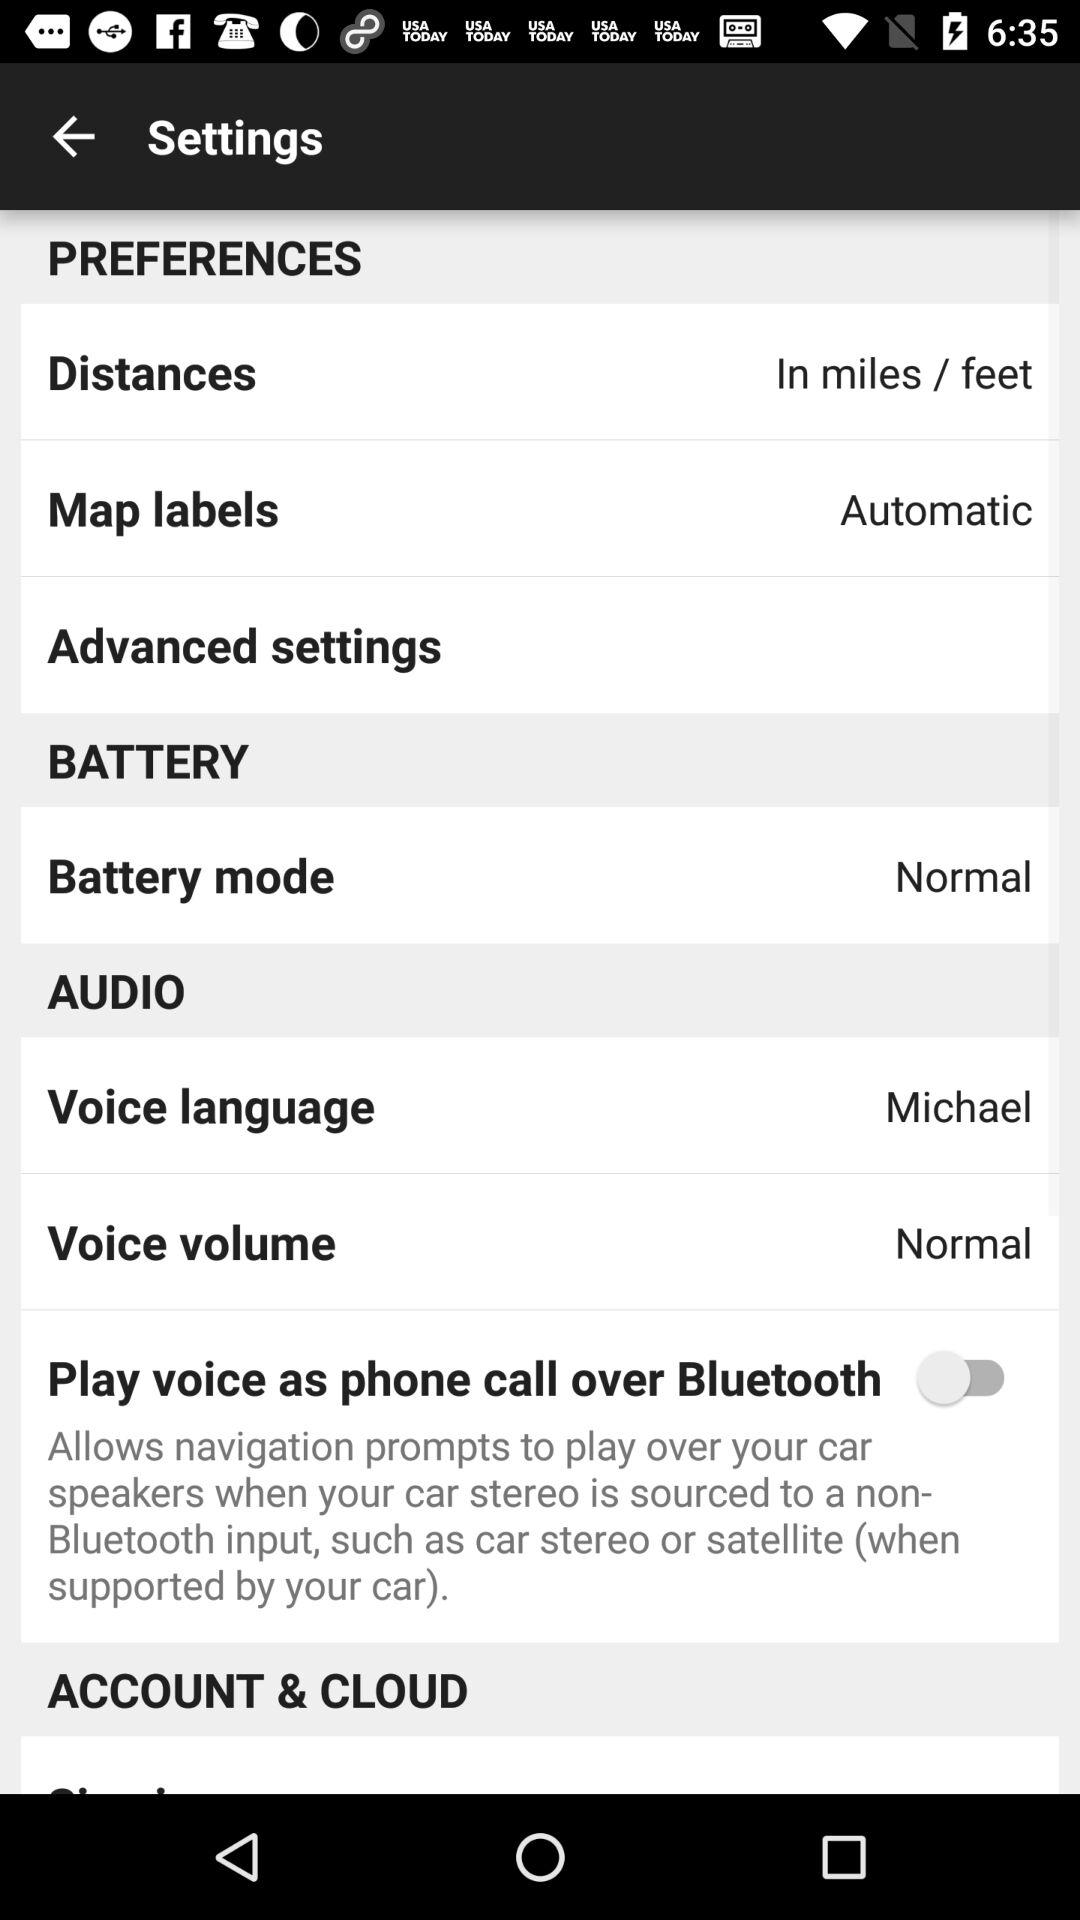What is the "Voice language"? The "Voice language" is "Michael". 